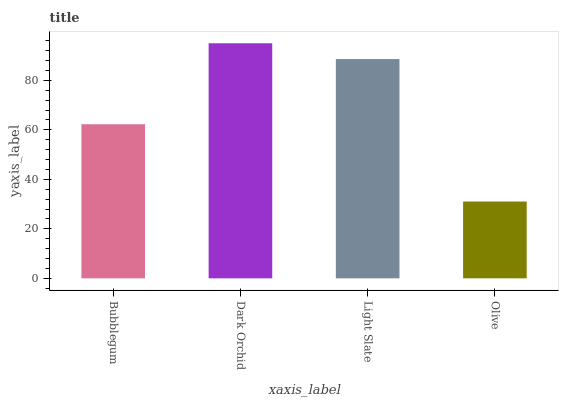Is Olive the minimum?
Answer yes or no. Yes. Is Dark Orchid the maximum?
Answer yes or no. Yes. Is Light Slate the minimum?
Answer yes or no. No. Is Light Slate the maximum?
Answer yes or no. No. Is Dark Orchid greater than Light Slate?
Answer yes or no. Yes. Is Light Slate less than Dark Orchid?
Answer yes or no. Yes. Is Light Slate greater than Dark Orchid?
Answer yes or no. No. Is Dark Orchid less than Light Slate?
Answer yes or no. No. Is Light Slate the high median?
Answer yes or no. Yes. Is Bubblegum the low median?
Answer yes or no. Yes. Is Bubblegum the high median?
Answer yes or no. No. Is Dark Orchid the low median?
Answer yes or no. No. 